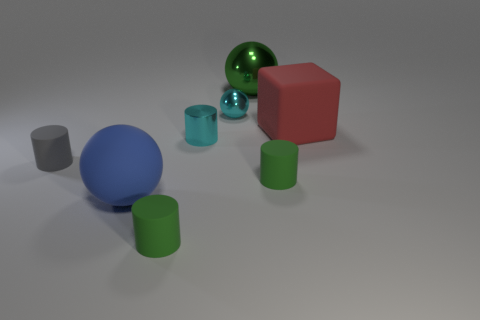Add 1 small brown things. How many objects exist? 9 Subtract all cyan blocks. Subtract all blue spheres. How many blocks are left? 1 Subtract all cubes. How many objects are left? 7 Subtract all red objects. Subtract all large green metallic things. How many objects are left? 6 Add 8 tiny green matte cylinders. How many tiny green matte cylinders are left? 10 Add 2 green rubber balls. How many green rubber balls exist? 2 Subtract 0 purple cubes. How many objects are left? 8 